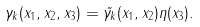<formula> <loc_0><loc_0><loc_500><loc_500>\gamma _ { k } ( x _ { 1 } , x _ { 2 } , x _ { 3 } ) = \tilde { \gamma _ { k } } ( x _ { 1 } , x _ { 2 } ) \eta ( x _ { 3 } ) .</formula> 